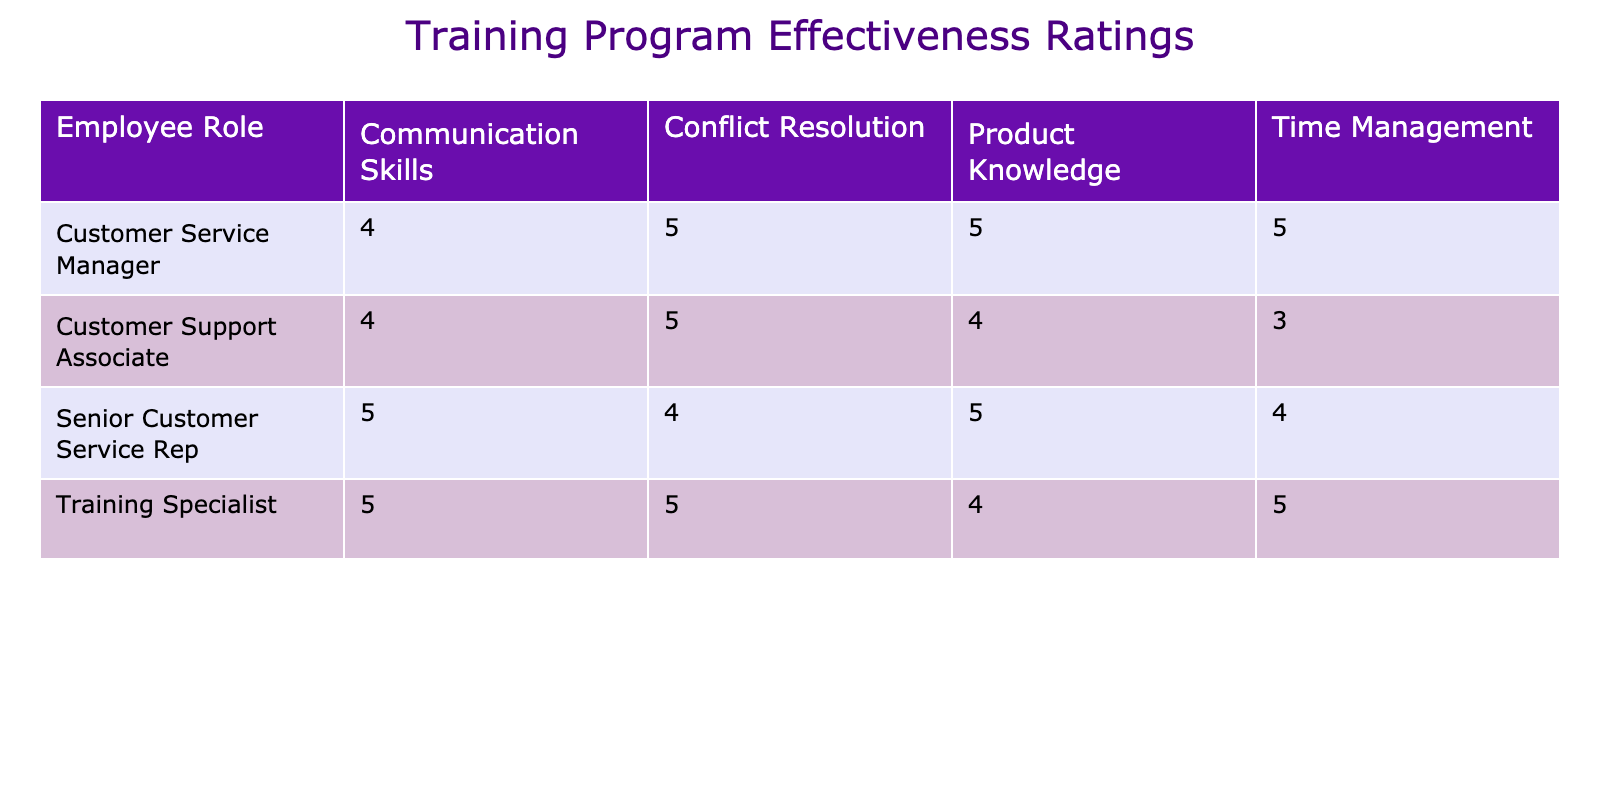What is the effectiveness rating for the Customer Support Associate in Conflict Resolution? The table indicates that the effectiveness rating for the Customer Support Associate in the Conflict Resolution session is 5. This can be directly found in the relevant row and column of the table.
Answer: 5 Which session type received the highest rating from the Senior Customer Service Rep? From the ratings listed for the Senior Customer Service Rep, the sessions are Product Knowledge (5), Conflict Resolution (4), Time Management (4), and Communication Skills (5). The highest rating found is 5, which appears for both Product Knowledge and Communication Skills.
Answer: 5 What is the average effectiveness rating for the Training Specialist across all session types? To calculate the average effectiveness rating for the Training Specialist, we need to sum the ratings: Product Knowledge (4) + Conflict Resolution (5) + Time Management (5) + Communication Skills (5) = 19. Since there are 4 ratings, we divide by 4: 19 ÷ 4 = 4.75.
Answer: 4.75 Did the Customer Service Manager give a rating of 4 for any session type? The Customer Service Manager's ratings for each session type are: Product Knowledge (5), Conflict Resolution (5), Time Management (5), and Communication Skills (4). Therefore, the statement is true, as there is indeed a session type (Communication Skills) rated 4.
Answer: Yes Which employee role has the lowest effectiveness rating in Time Management? The Time Management ratings are Customer Support Associate (3), Senior Customer Service Rep (4), Customer Service Manager (5), and Training Specialist (5). The lowest rating in this category is 3, which belongs to the Customer Support Associate.
Answer: Customer Support Associate What is the total effectiveness rating for the Senior Customer Service Rep across all session types? For the Senior Customer Service Rep, the individual session ratings are: Product Knowledge (5), Conflict Resolution (4), Time Management (4), and Communication Skills (5). Adding these gives a total of 5 + 4 + 4 + 5 = 18.
Answer: 18 Which session has the highest overall rating among all employee roles? To find the session with the highest overall rating, we look at the ratings for each session type across roles: Product Knowledge has ratings 4, 5, 5, 4; Conflict Resolution has ratings 5, 4, 5, 5; Time Management has ratings 3, 4, 5, 5; Communication Skills has ratings 4, 5, 4, 5. Summing each session gives: Product Knowledge (18), Conflict Resolution (19), Time Management (17), Communication Skills (18). The highest is for Conflict Resolution at 19.
Answer: Conflict Resolution 